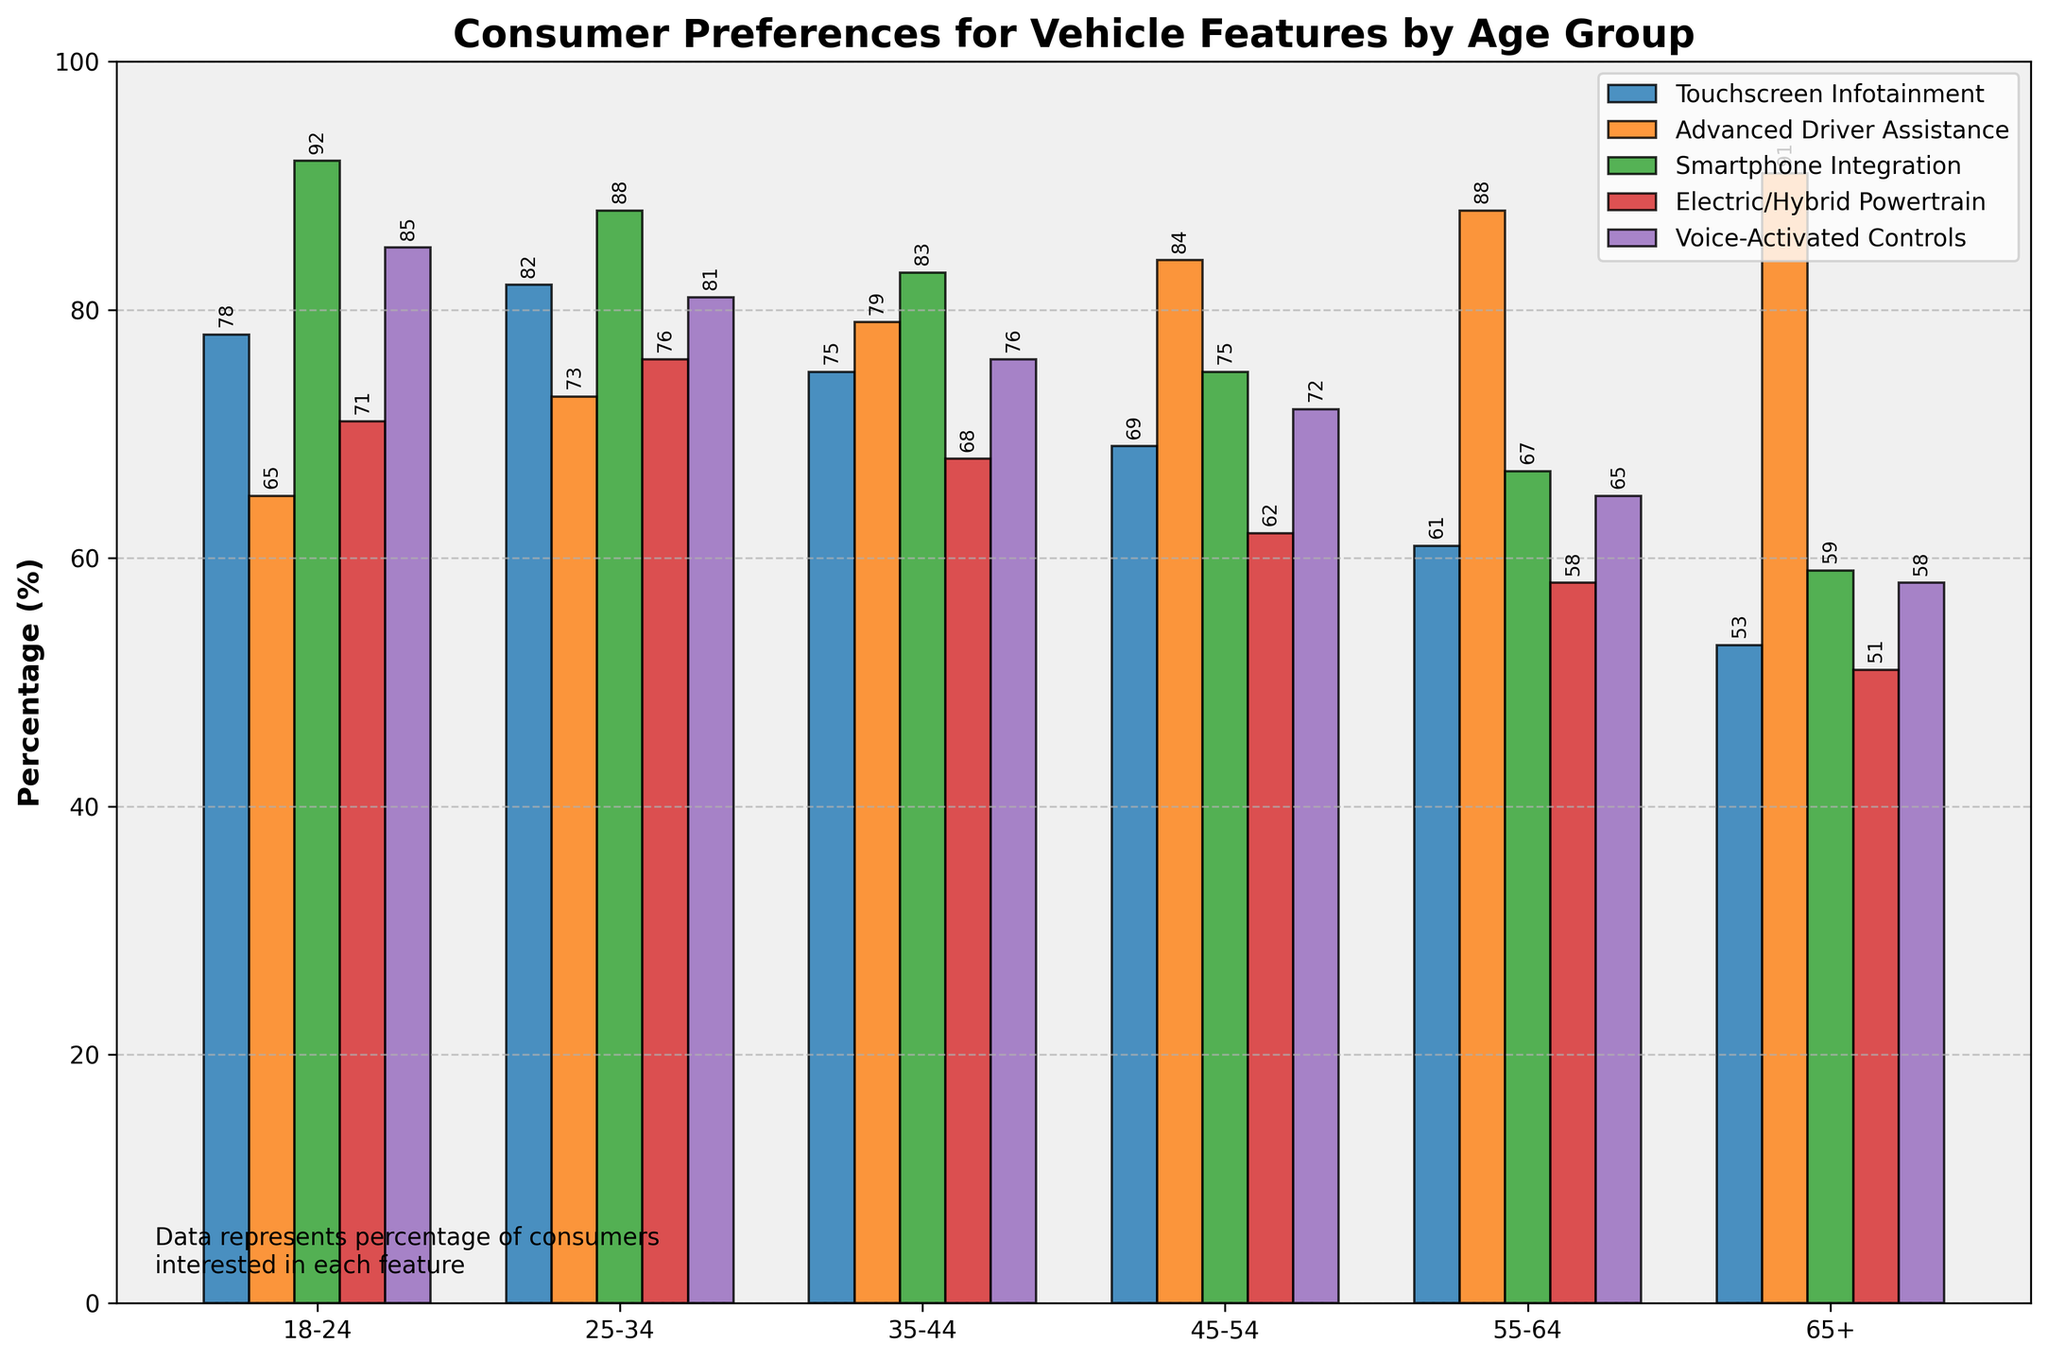What is the percentage preference for Touchscreen Infotainment among age groups 25-34 and 35-44, and what's the difference? The percentage preference for Touchscreen Infotainment in the age group 25-34 is 82%, and for the age group 35-44 is 75%. The difference is calculated as 82% - 75%.
Answer: 7% Which age group shows the highest preference for Voice-Activated Controls? By observing the height of the bars for Voice-Activated Controls, the 18-24 age group has the highest bar, representing 85%.
Answer: Age Group 18-24 Does the preference for Electric/Hybrid Powertrain increase or decrease with age? By examining each age group's preference for Electric/Hybrid Powertrain, you can see that the percentage decreases as the age group gets older: 18-24 (71%), 25-34 (76%), 35-44 (68%), 45-54 (62%), 55-64 (58%), 65+ (51%).
Answer: Decrease What is the average preference for Advanced Driver Assistance for all age groups? Sum the preference percentages for Advanced Driver Assistance across all age groups (65 + 73 + 79 + 84 + 88 + 91) and divide by the number of age groups (6). (65 + 73 + 79 + 84 + 88 + 91) / 6 = 80%.
Answer: 80% Compare and contrast the preference for Smartphone Integration between the youngest (18-24) and oldest (65+) age groups. The 18-24 age group has a preference of 92%, while the 65+ age group has a preference of 59%. The youngest group prefers Smartphone Integration significantly more than the oldest group by 33%.
Answer: The preference is 33% higher in the 18-24 age group For which feature is the preference most uniformly distributed across age groups? By comparing the height (or percentage values) for each feature across all age groups, Advanced Driver Assistance has the most uniform distribution with values ranging from 65% to 91%.
Answer: Advanced Driver Assistance Which age group has the lowest preference for Electric/Hybrid Powertrain? Examining the bar heights for Electric/Hybrid Powertrain across all age groups, the 65+ group has the smallest bar representing 51%.
Answer: Age Group 65+ What is the sum of preferences for all features for the age group 45-54? Add the percentage preferences for all features for the age group 45-54: 69 (Touchscreen Infotainment) + 84 (Advanced Driver Assistance) + 75 (Smartphone Integration) + 62 (Electric/Hybrid Powertrain) + 72 (Voice-Activated Controls). 69 + 84 + 75 + 62 + 72 = 362%.
Answer: 362% Which feature shows a decreasing trend as the age group gets older? By reviewing each feature's percentage across age groups, Electric/Hybrid Powertrain is observed to decrease from 71% to 51% as the age groups get older.
Answer: Electric/Hybrid Powertrain 